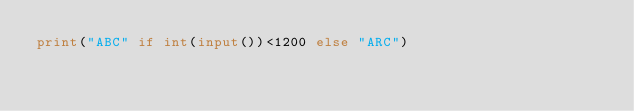Convert code to text. <code><loc_0><loc_0><loc_500><loc_500><_Python_>print("ABC" if int(input())<1200 else "ARC")</code> 